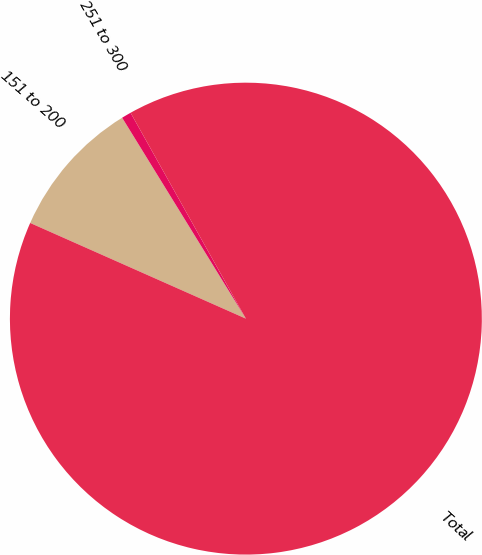<chart> <loc_0><loc_0><loc_500><loc_500><pie_chart><fcel>151 to 200<fcel>251 to 300<fcel>Total<nl><fcel>9.57%<fcel>0.66%<fcel>89.77%<nl></chart> 